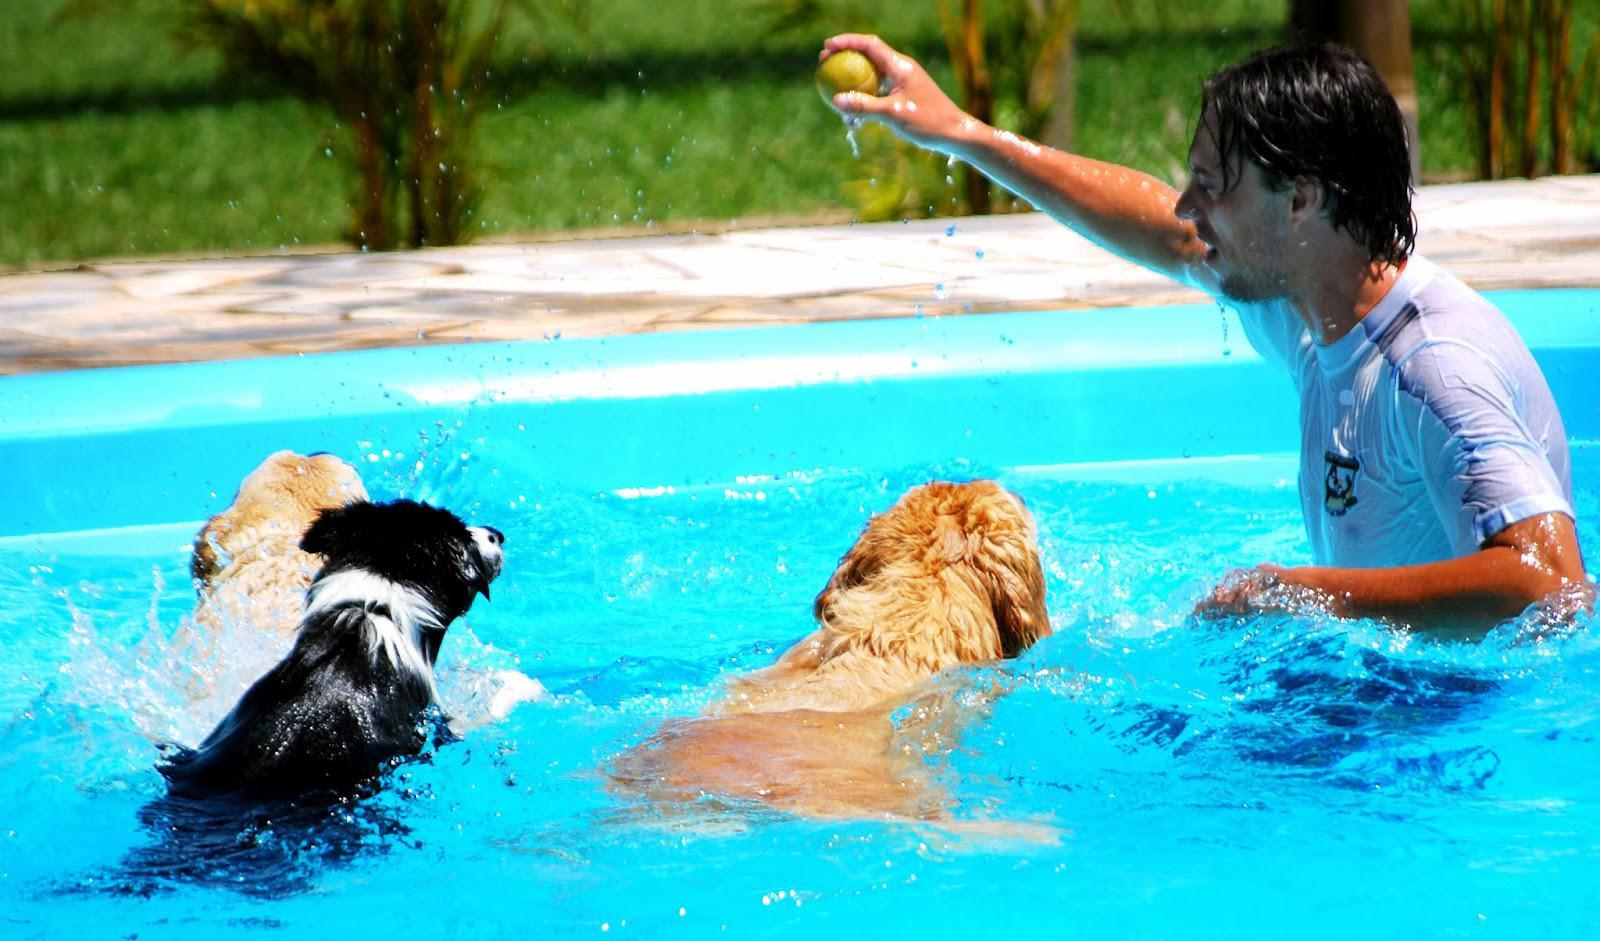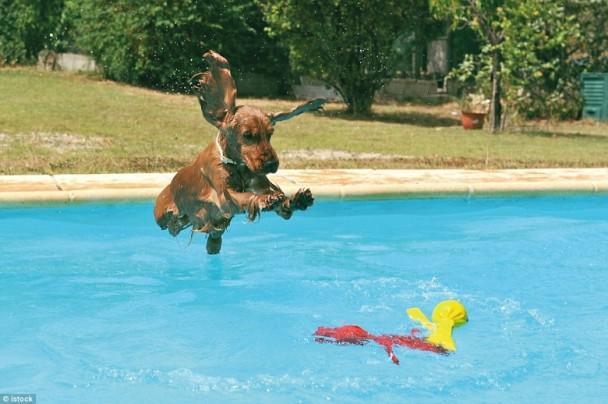The first image is the image on the left, the second image is the image on the right. Considering the images on both sides, is "A dog is in mid-leap over the blue water of a manmade pool." valid? Answer yes or no. Yes. The first image is the image on the left, the second image is the image on the right. Given the left and right images, does the statement "One of the dogs is using a floatation device in the pool." hold true? Answer yes or no. No. 